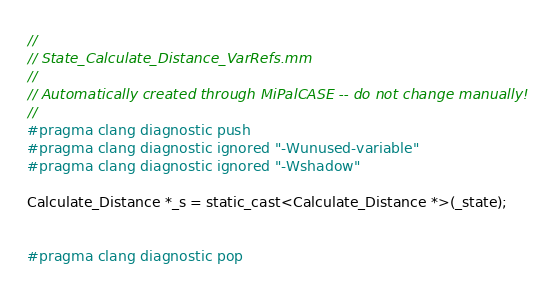<code> <loc_0><loc_0><loc_500><loc_500><_ObjectiveC_>//
// State_Calculate_Distance_VarRefs.mm
//
// Automatically created through MiPalCASE -- do not change manually!
//
#pragma clang diagnostic push
#pragma clang diagnostic ignored "-Wunused-variable"
#pragma clang diagnostic ignored "-Wshadow"

Calculate_Distance *_s = static_cast<Calculate_Distance *>(_state);


#pragma clang diagnostic pop
</code> 